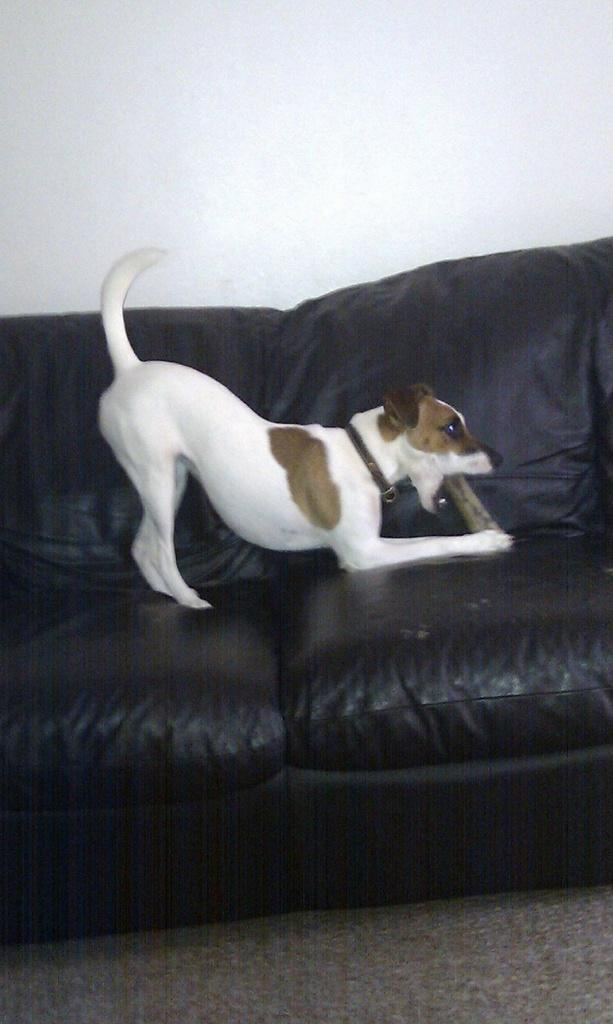What is on the sofa in the image? There is a dog on the sofa in the image. What can be seen in the background of the image? There is a wall in the background of the image. What type of pancake is the dog eating on the sofa? There is no pancake present in the image; the dog is simply sitting on the sofa. 